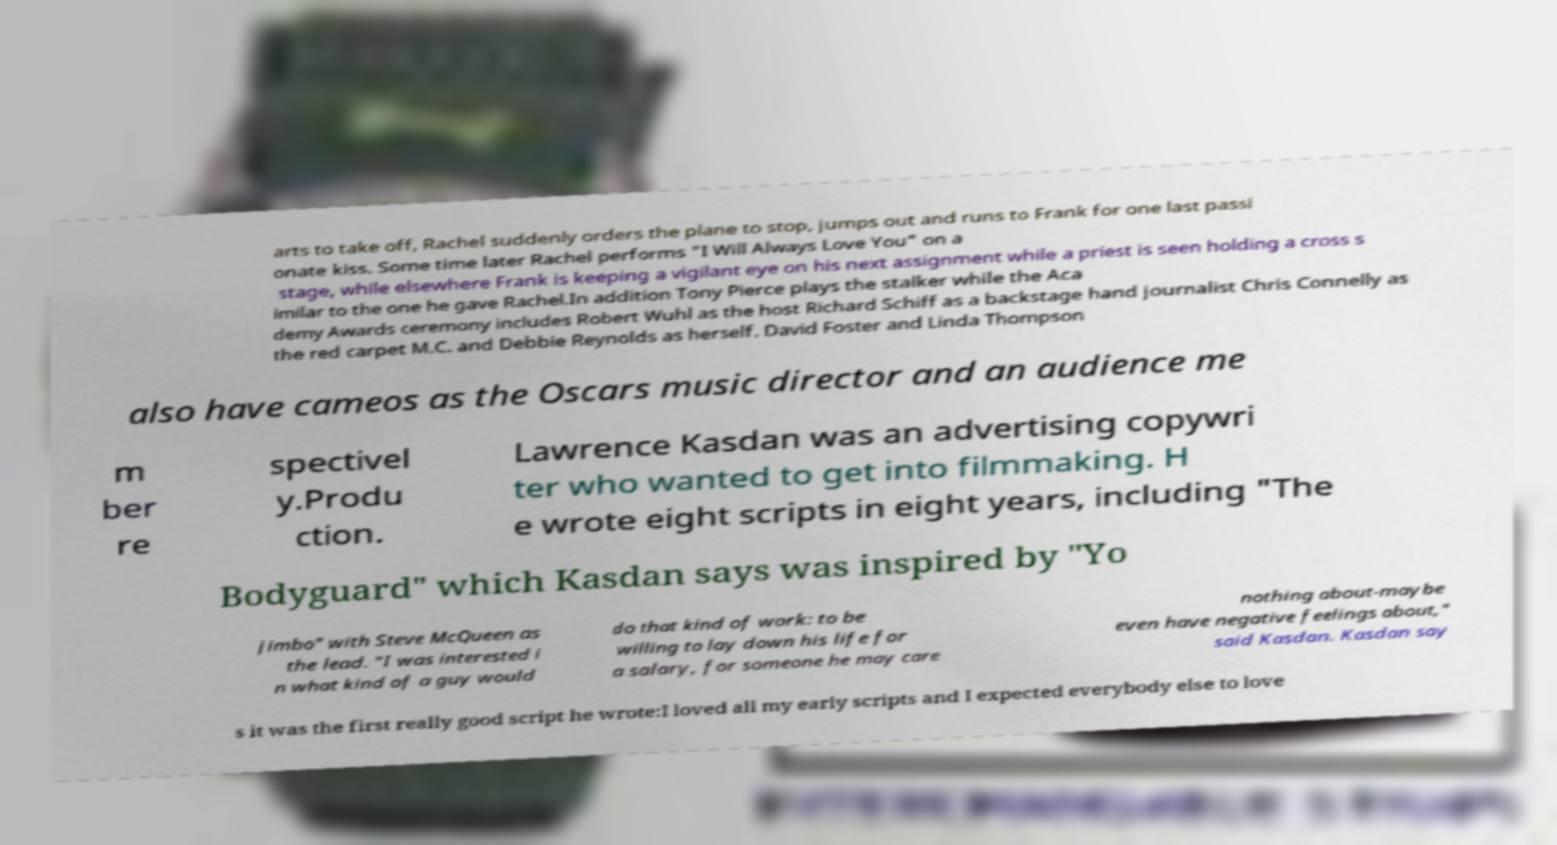Can you read and provide the text displayed in the image?This photo seems to have some interesting text. Can you extract and type it out for me? arts to take off, Rachel suddenly orders the plane to stop, jumps out and runs to Frank for one last passi onate kiss. Some time later Rachel performs "I Will Always Love You" on a stage, while elsewhere Frank is keeping a vigilant eye on his next assignment while a priest is seen holding a cross s imilar to the one he gave Rachel.In addition Tony Pierce plays the stalker while the Aca demy Awards ceremony includes Robert Wuhl as the host Richard Schiff as a backstage hand journalist Chris Connelly as the red carpet M.C. and Debbie Reynolds as herself. David Foster and Linda Thompson also have cameos as the Oscars music director and an audience me m ber re spectivel y.Produ ction. Lawrence Kasdan was an advertising copywri ter who wanted to get into filmmaking. H e wrote eight scripts in eight years, including "The Bodyguard" which Kasdan says was inspired by "Yo jimbo" with Steve McQueen as the lead. "I was interested i n what kind of a guy would do that kind of work: to be willing to lay down his life for a salary, for someone he may care nothing about-maybe even have negative feelings about," said Kasdan. Kasdan say s it was the first really good script he wrote:I loved all my early scripts and I expected everybody else to love 